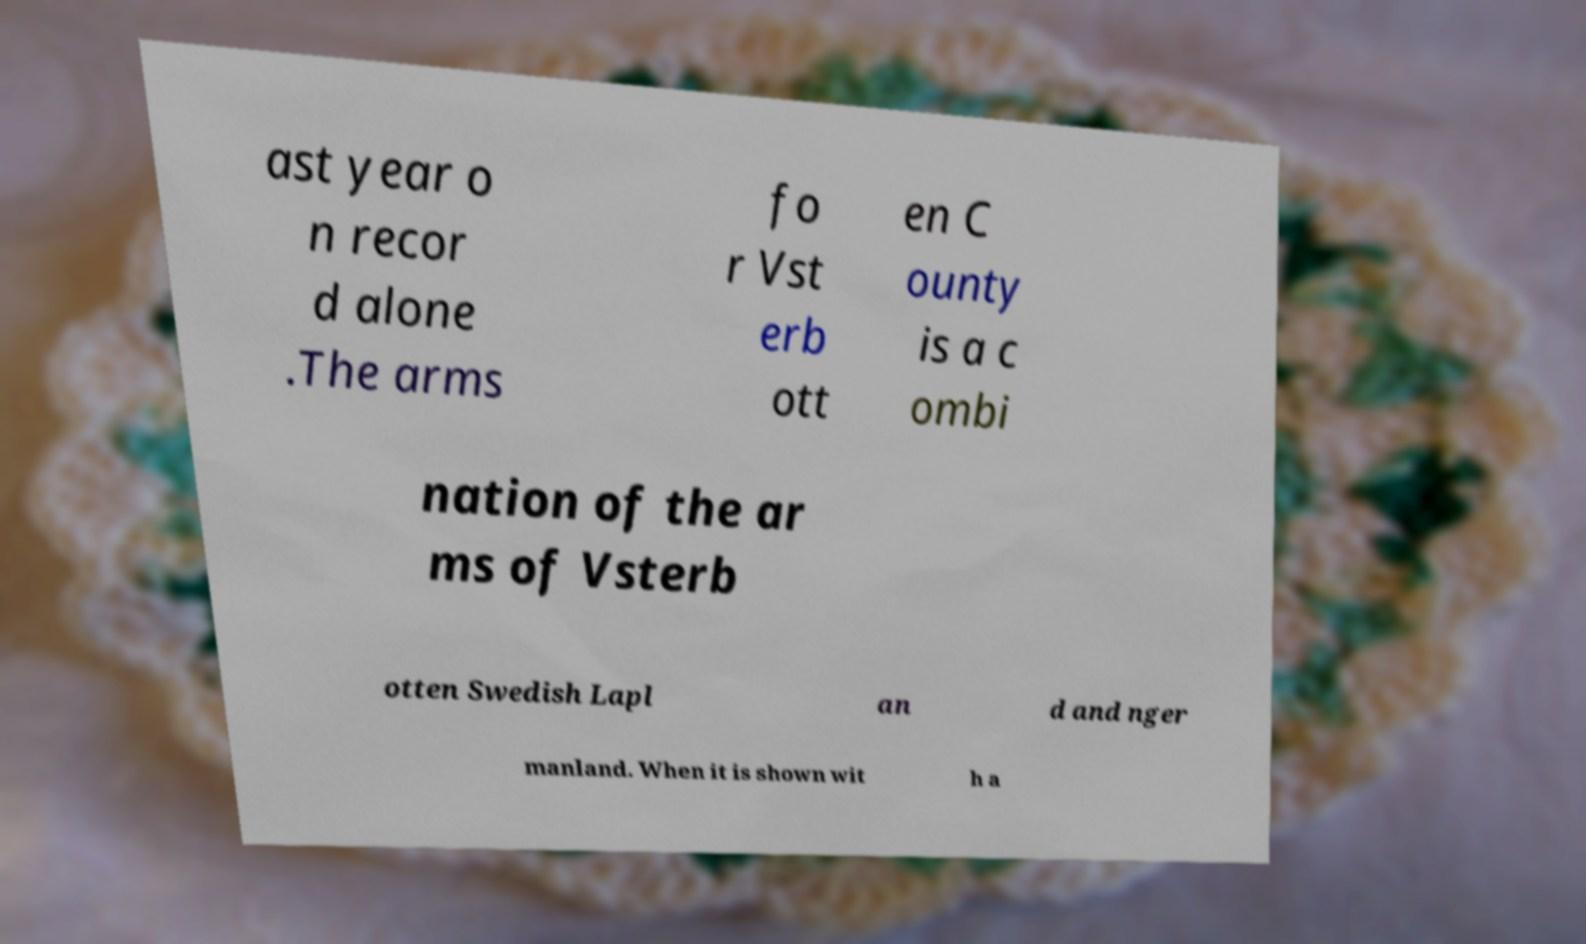For documentation purposes, I need the text within this image transcribed. Could you provide that? ast year o n recor d alone .The arms fo r Vst erb ott en C ounty is a c ombi nation of the ar ms of Vsterb otten Swedish Lapl an d and nger manland. When it is shown wit h a 